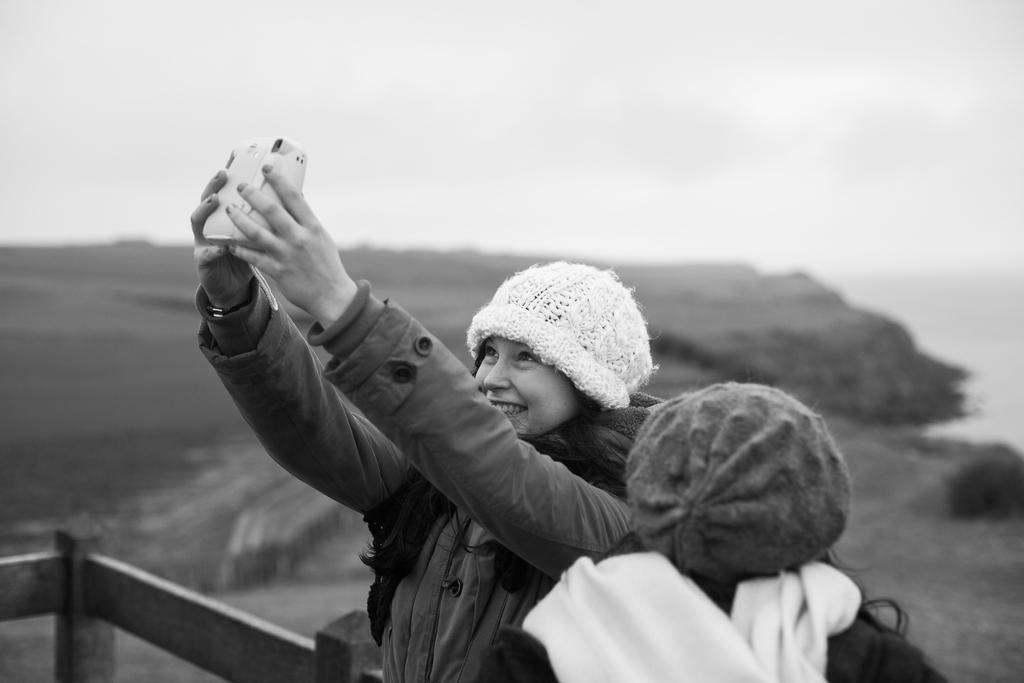Describe this image in one or two sentences. In this image there is a woman holding a camera, inside the woman there is another person, behind them there is a wooden fence, in the background of the image there is sea and landscape. 